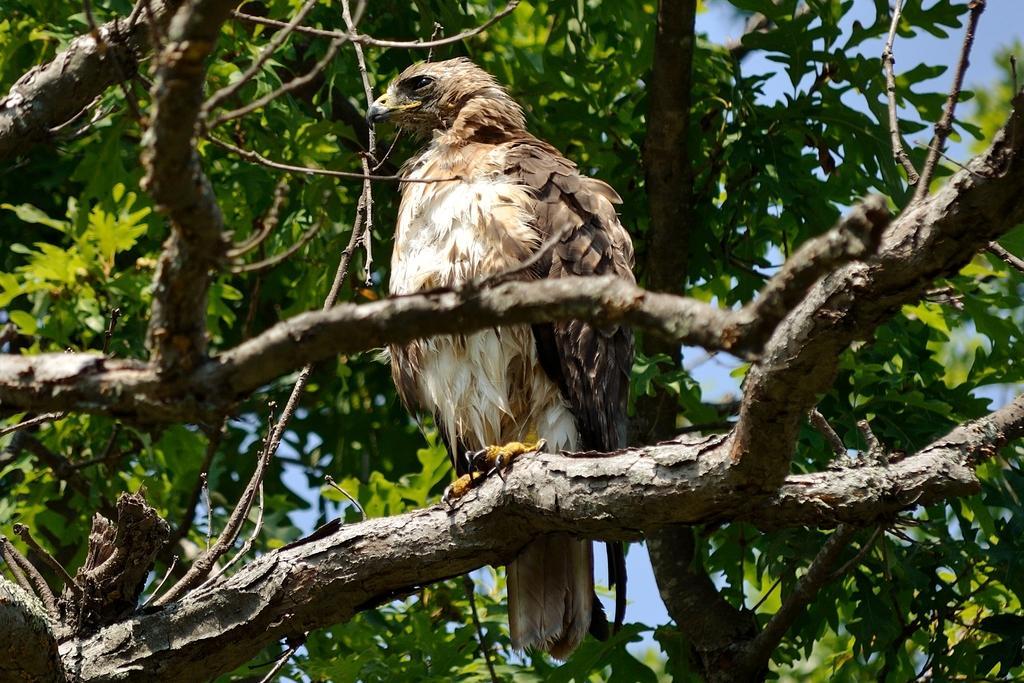Can you describe this image briefly? In the foreground there is a tree. There is a bird standing on the tree. At the top there is sky. 